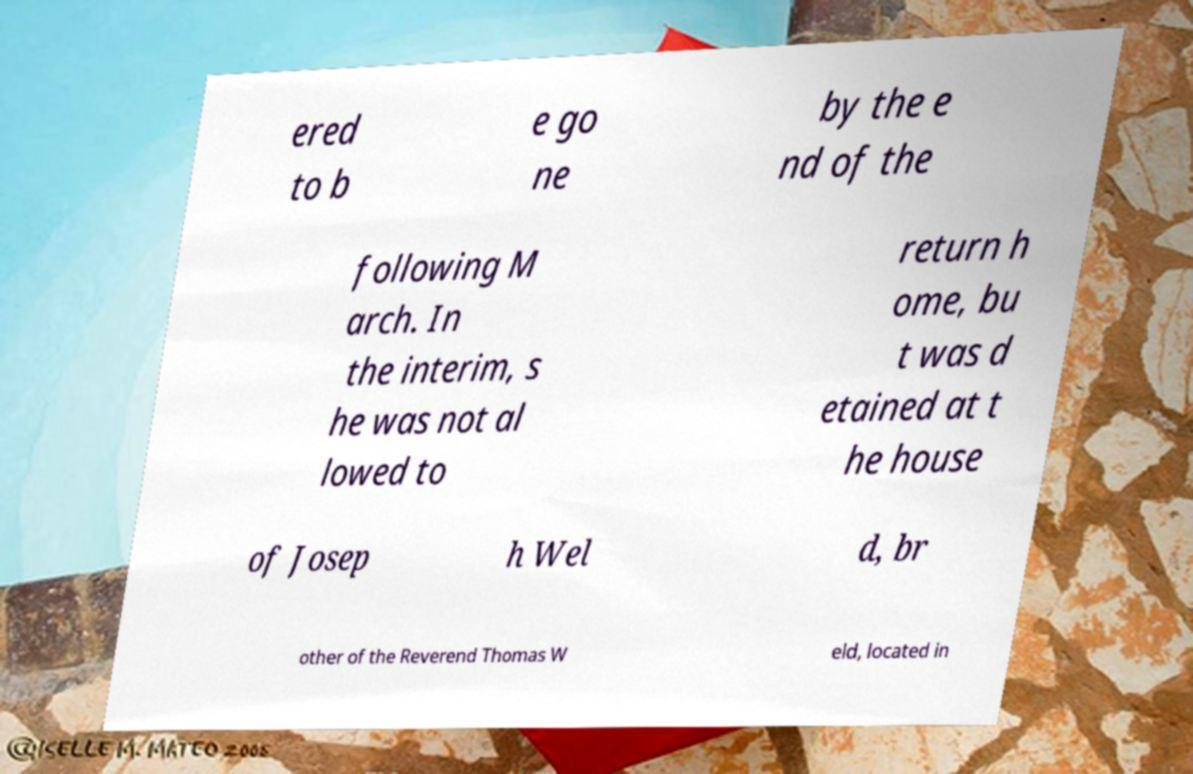Could you extract and type out the text from this image? ered to b e go ne by the e nd of the following M arch. In the interim, s he was not al lowed to return h ome, bu t was d etained at t he house of Josep h Wel d, br other of the Reverend Thomas W eld, located in 